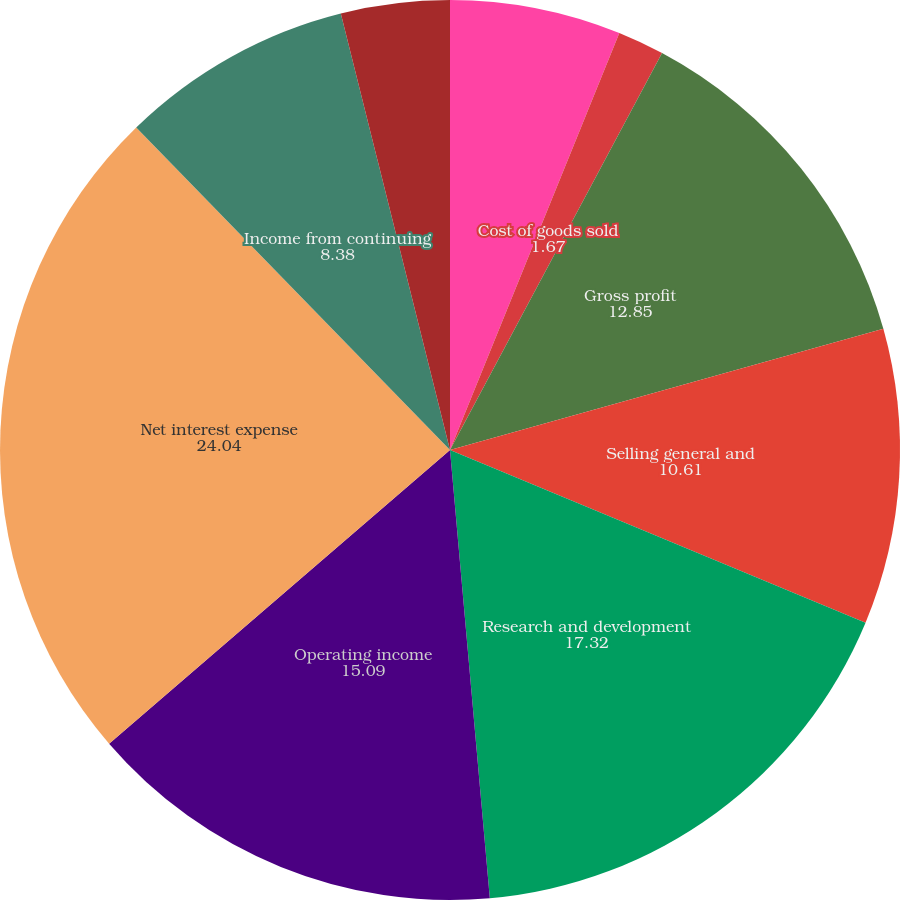Convert chart to OTSL. <chart><loc_0><loc_0><loc_500><loc_500><pie_chart><fcel>Net sales<fcel>Cost of goods sold<fcel>Gross profit<fcel>Selling general and<fcel>Research and development<fcel>Operating income<fcel>Net interest expense<fcel>Income from continuing<fcel>Provision for income taxes<nl><fcel>6.14%<fcel>1.67%<fcel>12.85%<fcel>10.61%<fcel>17.32%<fcel>15.09%<fcel>24.04%<fcel>8.38%<fcel>3.9%<nl></chart> 